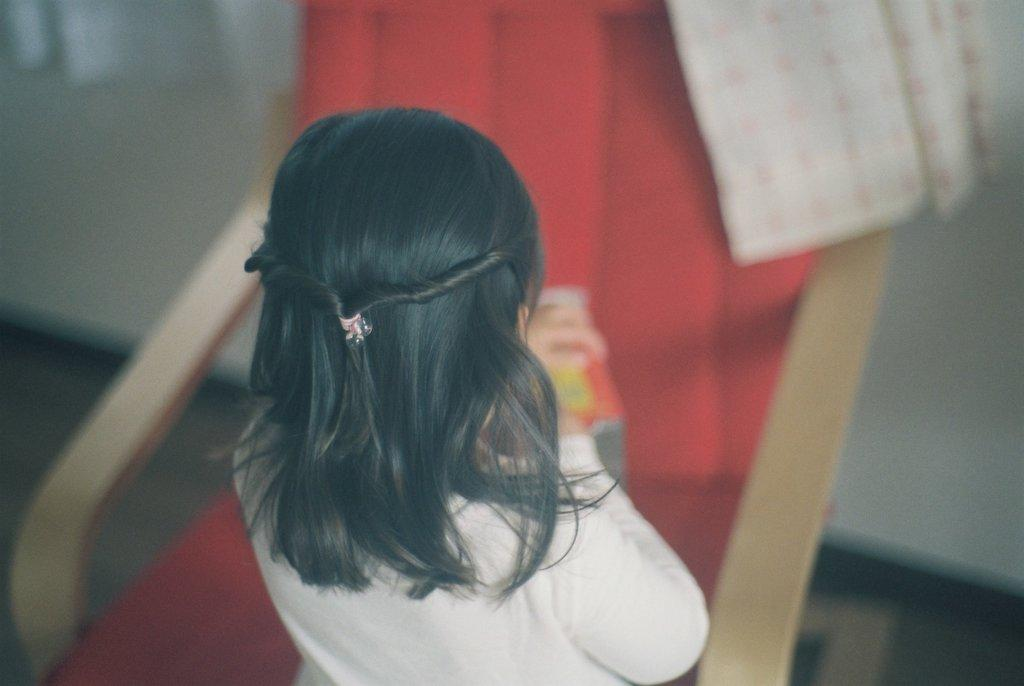Who is the main subject in the image? There is a girl in the center of the image. What is the girl's position in the image? The girl is on the floor. What can be seen in the background of the image? There is a chair and a wall in the background of the image. What type of string is the girl holding in the image? There is no string present in the image. How does the chicken interact with the girl in the image? There is no chicken present in the image. 